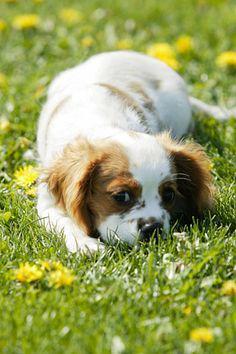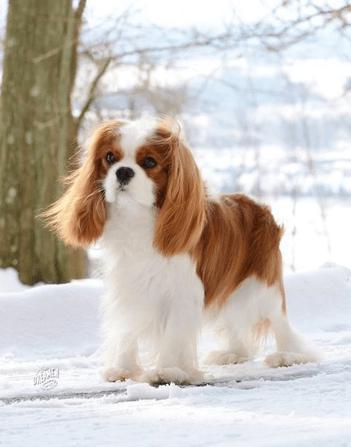The first image is the image on the left, the second image is the image on the right. Considering the images on both sides, is "There are three mammals visible" valid? Answer yes or no. No. The first image is the image on the left, the second image is the image on the right. Given the left and right images, does the statement "There is a single dog outside in each image." hold true? Answer yes or no. Yes. 